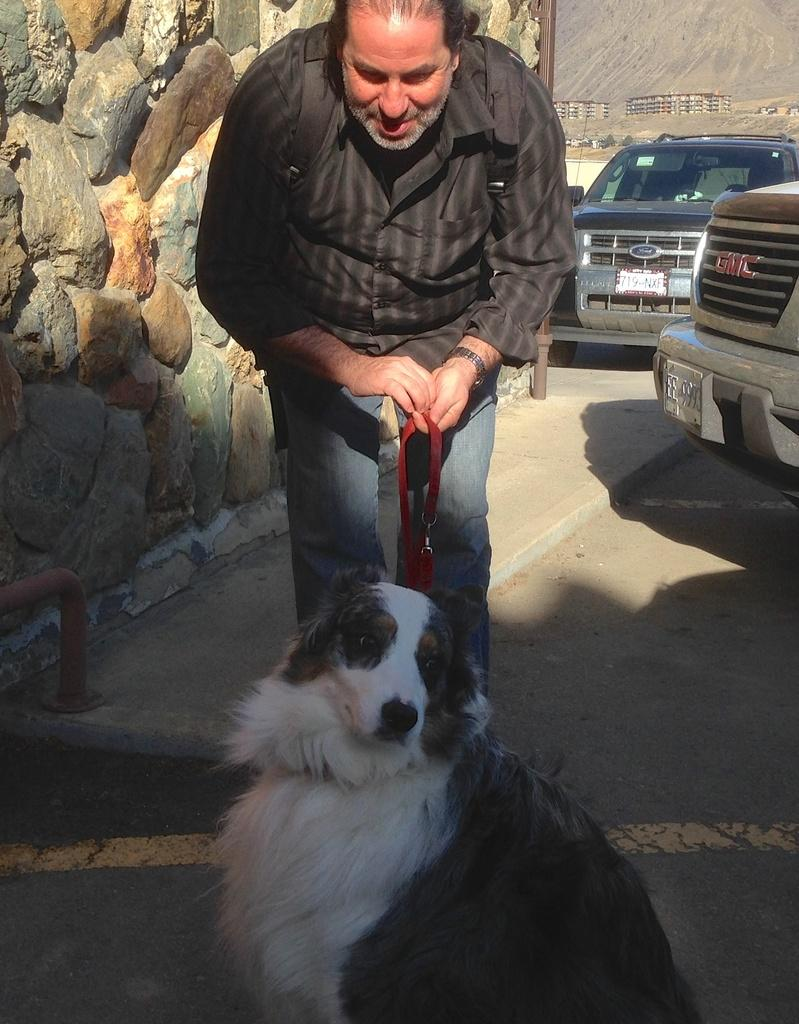Who is present in the image? There is a man in the image. What is the man doing in the image? The man is standing in the image. What is the man holding in the image? The man is holding a dog in the image. What type of clothing accessory is the man wearing? The man is wearing a belt in the image. What type of grain is being fed to the pigs in the image? There are no pigs or grain present in the image; it features a man holding a dog. How many bananas are visible in the image? There are no bananas present in the image. 